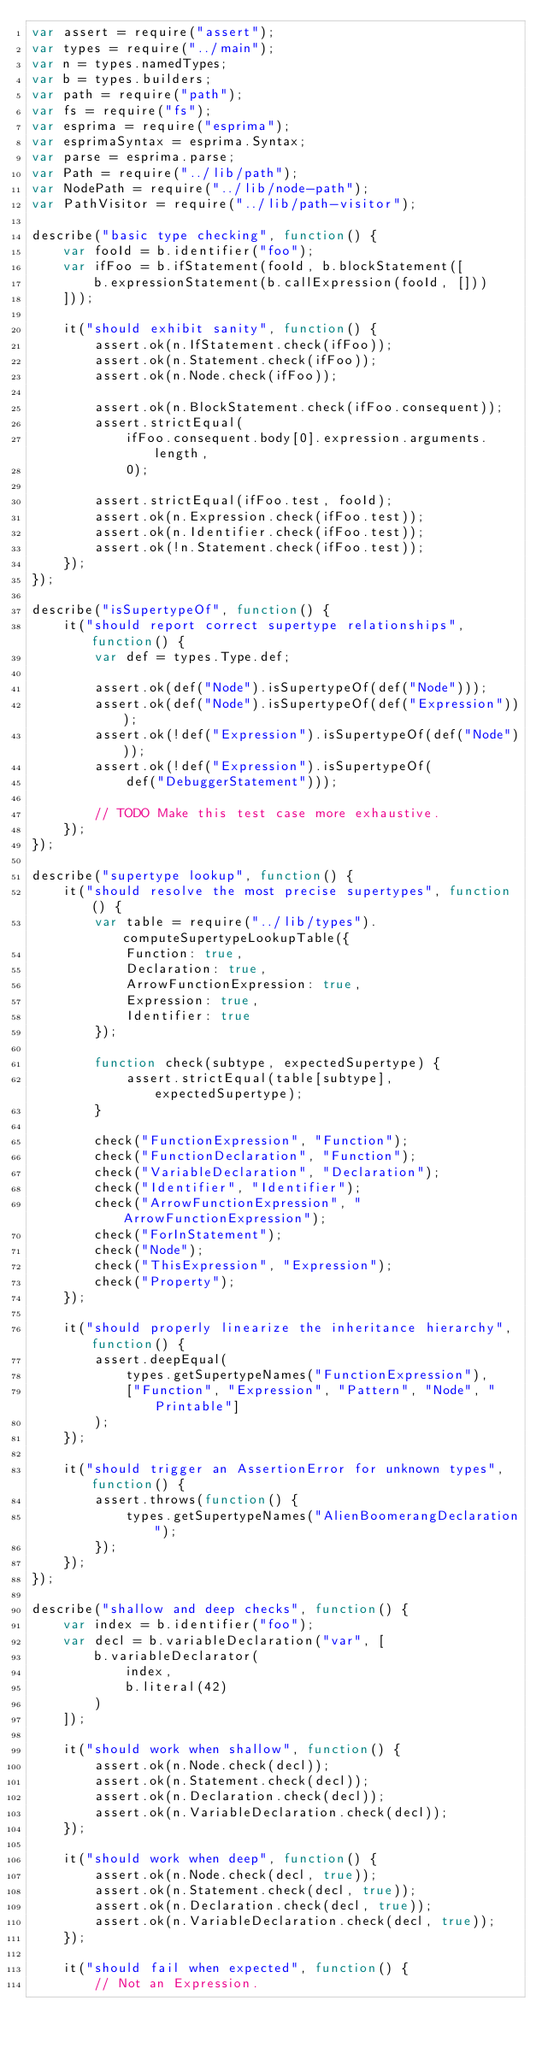Convert code to text. <code><loc_0><loc_0><loc_500><loc_500><_JavaScript_>var assert = require("assert");
var types = require("../main");
var n = types.namedTypes;
var b = types.builders;
var path = require("path");
var fs = require("fs");
var esprima = require("esprima");
var esprimaSyntax = esprima.Syntax;
var parse = esprima.parse;
var Path = require("../lib/path");
var NodePath = require("../lib/node-path");
var PathVisitor = require("../lib/path-visitor");

describe("basic type checking", function() {
    var fooId = b.identifier("foo");
    var ifFoo = b.ifStatement(fooId, b.blockStatement([
        b.expressionStatement(b.callExpression(fooId, []))
    ]));

    it("should exhibit sanity", function() {
        assert.ok(n.IfStatement.check(ifFoo));
        assert.ok(n.Statement.check(ifFoo));
        assert.ok(n.Node.check(ifFoo));

        assert.ok(n.BlockStatement.check(ifFoo.consequent));
        assert.strictEqual(
            ifFoo.consequent.body[0].expression.arguments.length,
            0);

        assert.strictEqual(ifFoo.test, fooId);
        assert.ok(n.Expression.check(ifFoo.test));
        assert.ok(n.Identifier.check(ifFoo.test));
        assert.ok(!n.Statement.check(ifFoo.test));
    });
});

describe("isSupertypeOf", function() {
    it("should report correct supertype relationships", function() {
        var def = types.Type.def;

        assert.ok(def("Node").isSupertypeOf(def("Node")));
        assert.ok(def("Node").isSupertypeOf(def("Expression")));
        assert.ok(!def("Expression").isSupertypeOf(def("Node")));
        assert.ok(!def("Expression").isSupertypeOf(
            def("DebuggerStatement")));

        // TODO Make this test case more exhaustive.
    });
});

describe("supertype lookup", function() {
    it("should resolve the most precise supertypes", function() {
        var table = require("../lib/types").computeSupertypeLookupTable({
            Function: true,
            Declaration: true,
            ArrowFunctionExpression: true,
            Expression: true,
            Identifier: true
        });

        function check(subtype, expectedSupertype) {
            assert.strictEqual(table[subtype], expectedSupertype);
        }

        check("FunctionExpression", "Function");
        check("FunctionDeclaration", "Function");
        check("VariableDeclaration", "Declaration");
        check("Identifier", "Identifier");
        check("ArrowFunctionExpression", "ArrowFunctionExpression");
        check("ForInStatement");
        check("Node");
        check("ThisExpression", "Expression");
        check("Property");
    });

    it("should properly linearize the inheritance hierarchy", function() {
        assert.deepEqual(
            types.getSupertypeNames("FunctionExpression"),
            ["Function", "Expression", "Pattern", "Node", "Printable"]
        );
    });

    it("should trigger an AssertionError for unknown types", function() {
        assert.throws(function() {
            types.getSupertypeNames("AlienBoomerangDeclaration");
        });
    });
});

describe("shallow and deep checks", function() {
    var index = b.identifier("foo");
    var decl = b.variableDeclaration("var", [
        b.variableDeclarator(
            index,
            b.literal(42)
        )
    ]);

    it("should work when shallow", function() {
        assert.ok(n.Node.check(decl));
        assert.ok(n.Statement.check(decl));
        assert.ok(n.Declaration.check(decl));
        assert.ok(n.VariableDeclaration.check(decl));
    });

    it("should work when deep", function() {
        assert.ok(n.Node.check(decl, true));
        assert.ok(n.Statement.check(decl, true));
        assert.ok(n.Declaration.check(decl, true));
        assert.ok(n.VariableDeclaration.check(decl, true));
    });

    it("should fail when expected", function() {
        // Not an Expression.</code> 